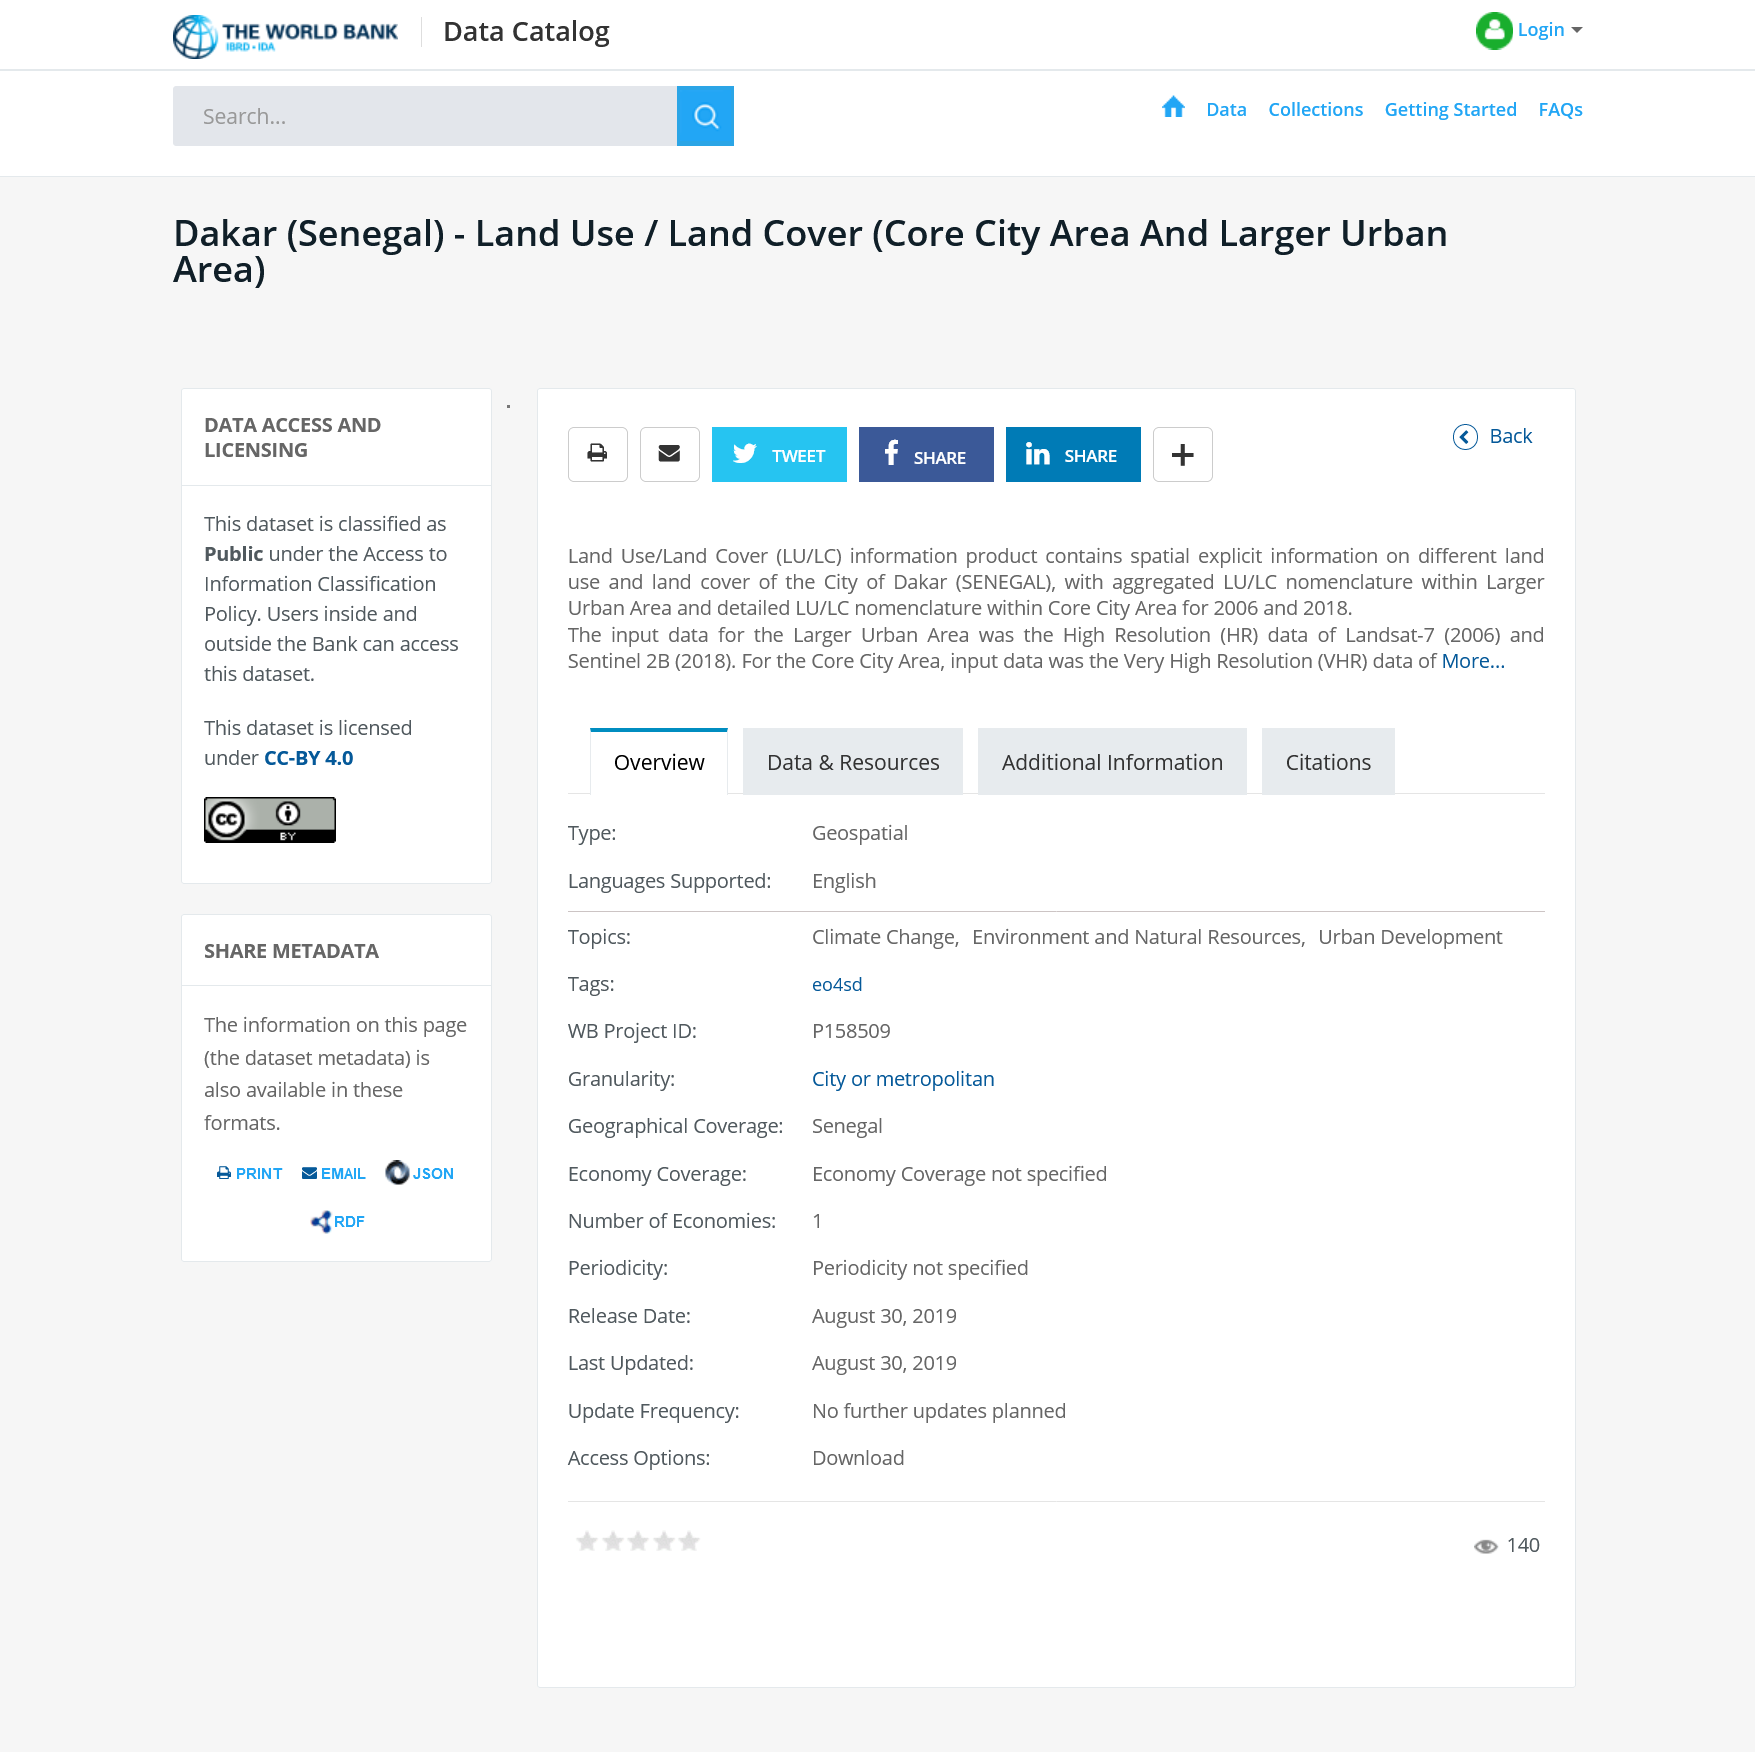Outline some significant characteristics in this image. Land Use/Land Cover (LU/LC) is a system used to describe the various ways that land is used and the types of land cover found in a particular area. This dataset is classified as public. This article can be shared on social platforms such as Twitter, Facebook, and Instagram. 